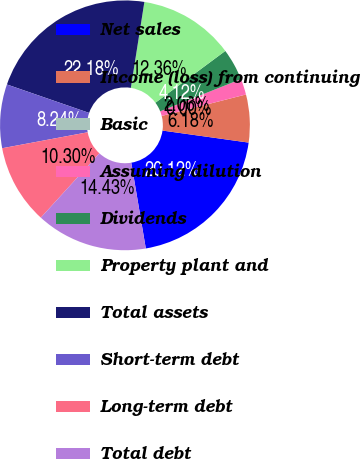<chart> <loc_0><loc_0><loc_500><loc_500><pie_chart><fcel>Net sales<fcel>Income (loss) from continuing<fcel>Basic<fcel>Assuming dilution<fcel>Dividends<fcel>Property plant and<fcel>Total assets<fcel>Short-term debt<fcel>Long-term debt<fcel>Total debt<nl><fcel>20.12%<fcel>6.18%<fcel>0.0%<fcel>2.06%<fcel>4.12%<fcel>12.36%<fcel>22.18%<fcel>8.24%<fcel>10.3%<fcel>14.43%<nl></chart> 